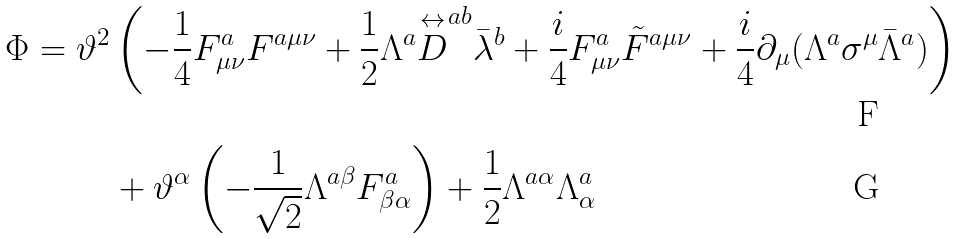Convert formula to latex. <formula><loc_0><loc_0><loc_500><loc_500>\Phi = \vartheta ^ { 2 } & \left ( - \frac { 1 } { 4 } F ^ { a } _ { \mu \nu } F ^ { a \mu \nu } + \frac { 1 } { 2 } \Lambda ^ { a } \overset { \leftrightarrow } { D } ^ { a b } \bar { \lambda } ^ { b } + \frac { i } { 4 } F ^ { a } _ { \mu \nu } \tilde { F } ^ { a \mu \nu } + \frac { i } { 4 } \partial _ { \mu } ( \Lambda ^ { a } \sigma ^ { \mu } \bar { \Lambda } ^ { a } ) \right ) \\ & + \vartheta ^ { \alpha } \left ( - \frac { 1 } { \sqrt { 2 } } \Lambda ^ { a \beta } F ^ { a } _ { \beta \alpha } \right ) + \frac { 1 } { 2 } \Lambda ^ { a \alpha } \Lambda ^ { a } _ { \alpha }</formula> 